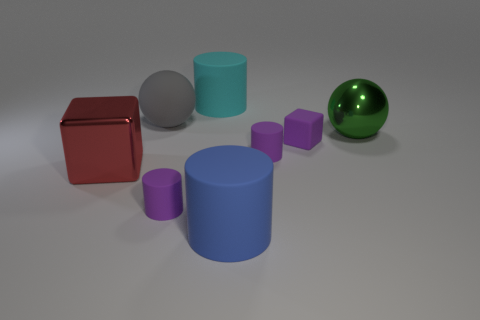Subtract all big blue rubber cylinders. How many cylinders are left? 3 Add 1 blue cylinders. How many objects exist? 9 Subtract all red cylinders. Subtract all red balls. How many cylinders are left? 4 Subtract all spheres. How many objects are left? 6 Add 8 cyan rubber cylinders. How many cyan rubber cylinders exist? 9 Subtract 1 purple cubes. How many objects are left? 7 Subtract all cyan things. Subtract all big green objects. How many objects are left? 6 Add 5 cyan cylinders. How many cyan cylinders are left? 6 